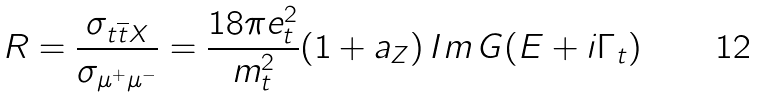<formula> <loc_0><loc_0><loc_500><loc_500>R = \frac { \sigma _ { t \overline { t } X } } { \sigma _ { \mu ^ { + } \mu ^ { - } } } = \frac { 1 8 \pi e ^ { 2 } _ { t } } { m _ { t } ^ { 2 } } ( 1 + a _ { Z } ) \, I m \, G ( E + i \Gamma _ { t } )</formula> 